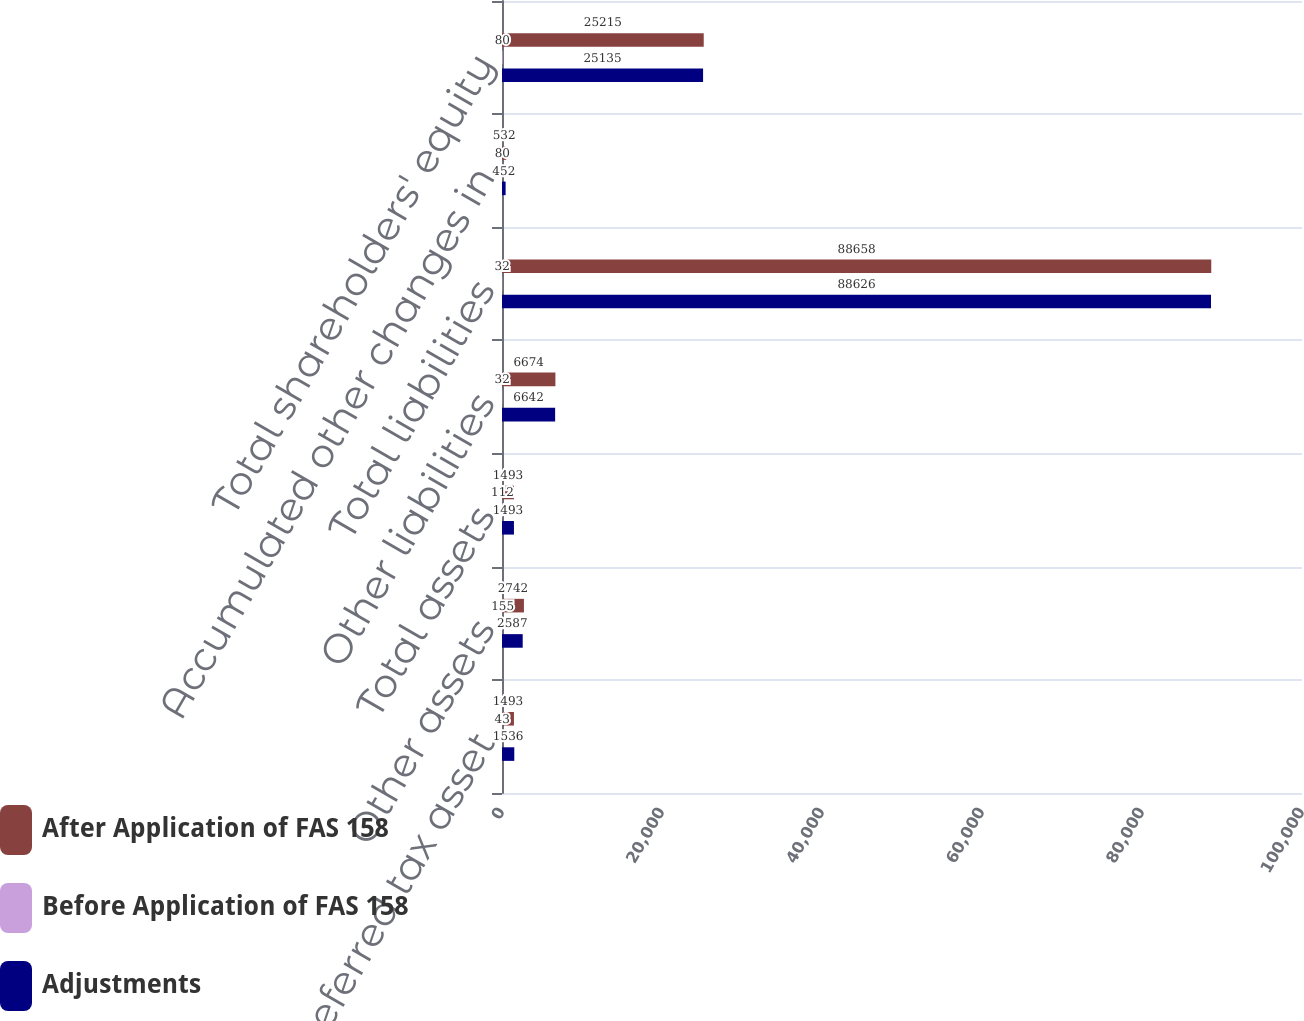<chart> <loc_0><loc_0><loc_500><loc_500><stacked_bar_chart><ecel><fcel>Deferred tax asset<fcel>Other assets<fcel>Total assets<fcel>Other liabilities<fcel>Total liabilities<fcel>Accumulated other changes in<fcel>Total shareholders' equity<nl><fcel>After Application of FAS 158<fcel>1493<fcel>2742<fcel>1493<fcel>6674<fcel>88658<fcel>532<fcel>25215<nl><fcel>Before Application of FAS 158<fcel>43<fcel>155<fcel>112<fcel>32<fcel>32<fcel>80<fcel>80<nl><fcel>Adjustments<fcel>1536<fcel>2587<fcel>1493<fcel>6642<fcel>88626<fcel>452<fcel>25135<nl></chart> 